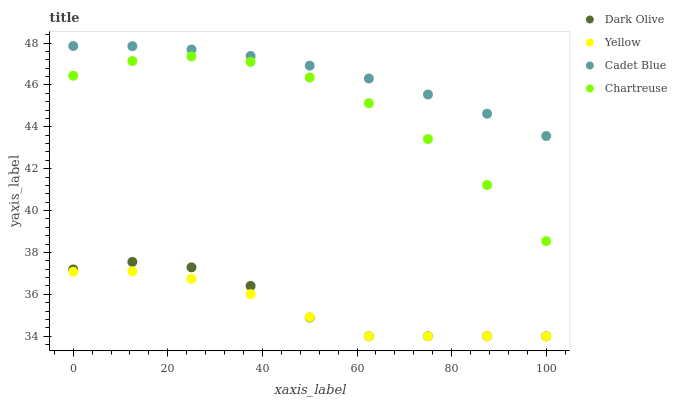Does Yellow have the minimum area under the curve?
Answer yes or no. Yes. Does Cadet Blue have the maximum area under the curve?
Answer yes or no. Yes. Does Chartreuse have the minimum area under the curve?
Answer yes or no. No. Does Chartreuse have the maximum area under the curve?
Answer yes or no. No. Is Cadet Blue the smoothest?
Answer yes or no. Yes. Is Chartreuse the roughest?
Answer yes or no. Yes. Is Dark Olive the smoothest?
Answer yes or no. No. Is Dark Olive the roughest?
Answer yes or no. No. Does Dark Olive have the lowest value?
Answer yes or no. Yes. Does Chartreuse have the lowest value?
Answer yes or no. No. Does Cadet Blue have the highest value?
Answer yes or no. Yes. Does Chartreuse have the highest value?
Answer yes or no. No. Is Dark Olive less than Cadet Blue?
Answer yes or no. Yes. Is Cadet Blue greater than Yellow?
Answer yes or no. Yes. Does Yellow intersect Dark Olive?
Answer yes or no. Yes. Is Yellow less than Dark Olive?
Answer yes or no. No. Is Yellow greater than Dark Olive?
Answer yes or no. No. Does Dark Olive intersect Cadet Blue?
Answer yes or no. No. 